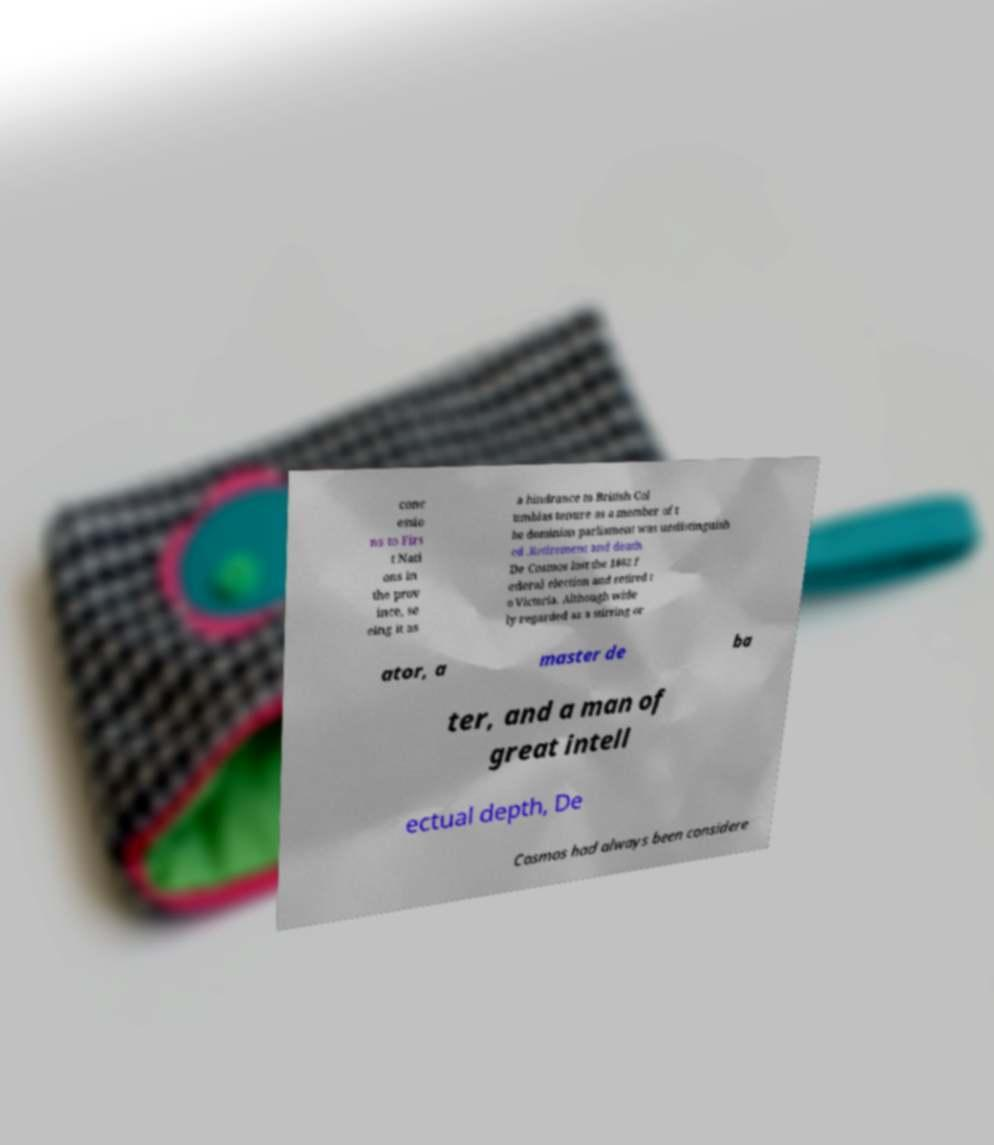Please read and relay the text visible in this image. What does it say? conc essio ns to Firs t Nati ons in the prov ince, se eing it as a hindrance to British Col umbias tenure as a member of t he dominion parliament was undistinguish ed .Retirement and death. De Cosmos lost the 1882 f ederal election and retired t o Victoria. Although wide ly regarded as a stirring or ator, a master de ba ter, and a man of great intell ectual depth, De Cosmos had always been considere 